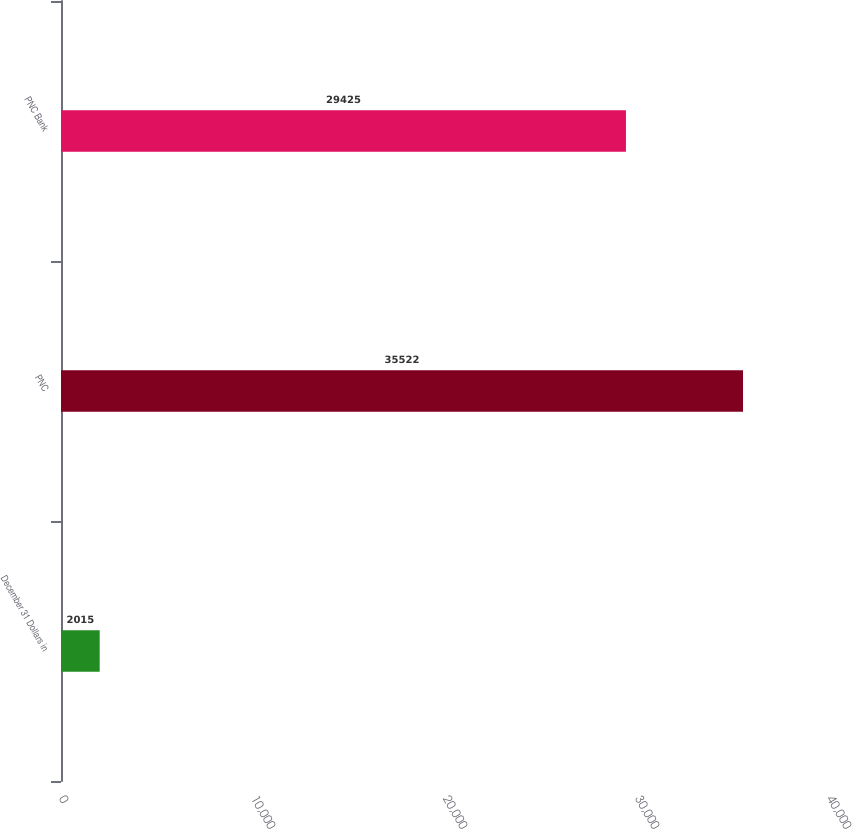<chart> <loc_0><loc_0><loc_500><loc_500><bar_chart><fcel>December 31 Dollars in<fcel>PNC<fcel>PNC Bank<nl><fcel>2015<fcel>35522<fcel>29425<nl></chart> 